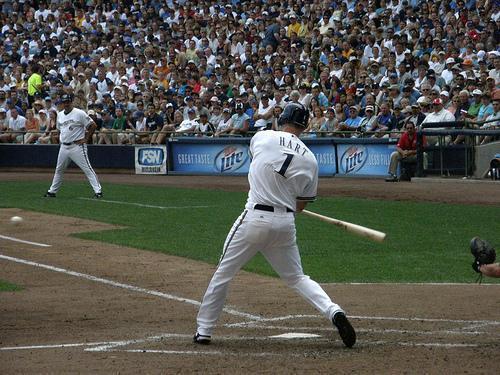How many players are in white?
Give a very brief answer. 2. How many people are there?
Give a very brief answer. 3. 